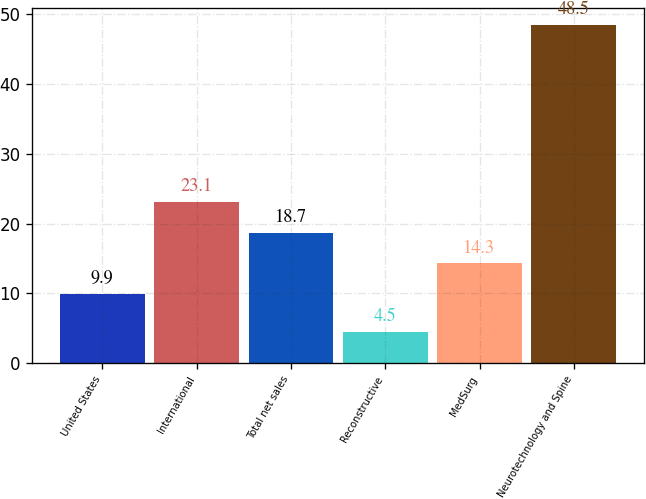<chart> <loc_0><loc_0><loc_500><loc_500><bar_chart><fcel>United States<fcel>International<fcel>Total net sales<fcel>Reconstructive<fcel>MedSurg<fcel>Neurotechnology and Spine<nl><fcel>9.9<fcel>23.1<fcel>18.7<fcel>4.5<fcel>14.3<fcel>48.5<nl></chart> 